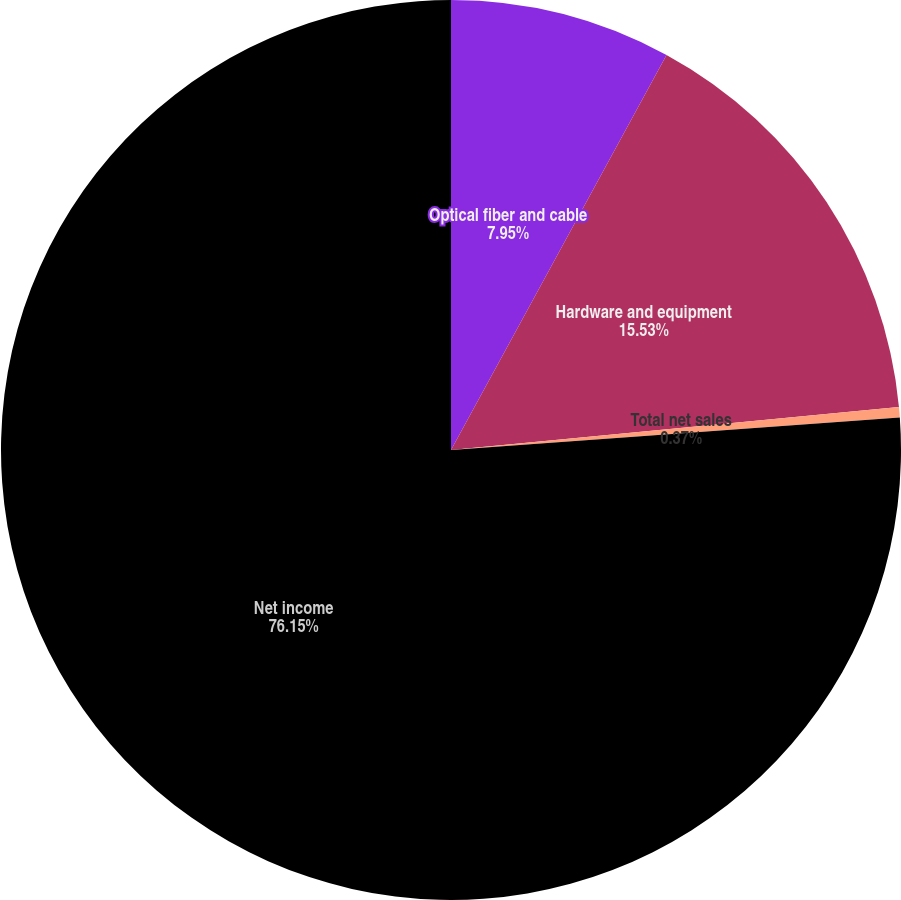Convert chart to OTSL. <chart><loc_0><loc_0><loc_500><loc_500><pie_chart><fcel>Optical fiber and cable<fcel>Hardware and equipment<fcel>Total net sales<fcel>Net income<nl><fcel>7.95%<fcel>15.53%<fcel>0.37%<fcel>76.16%<nl></chart> 